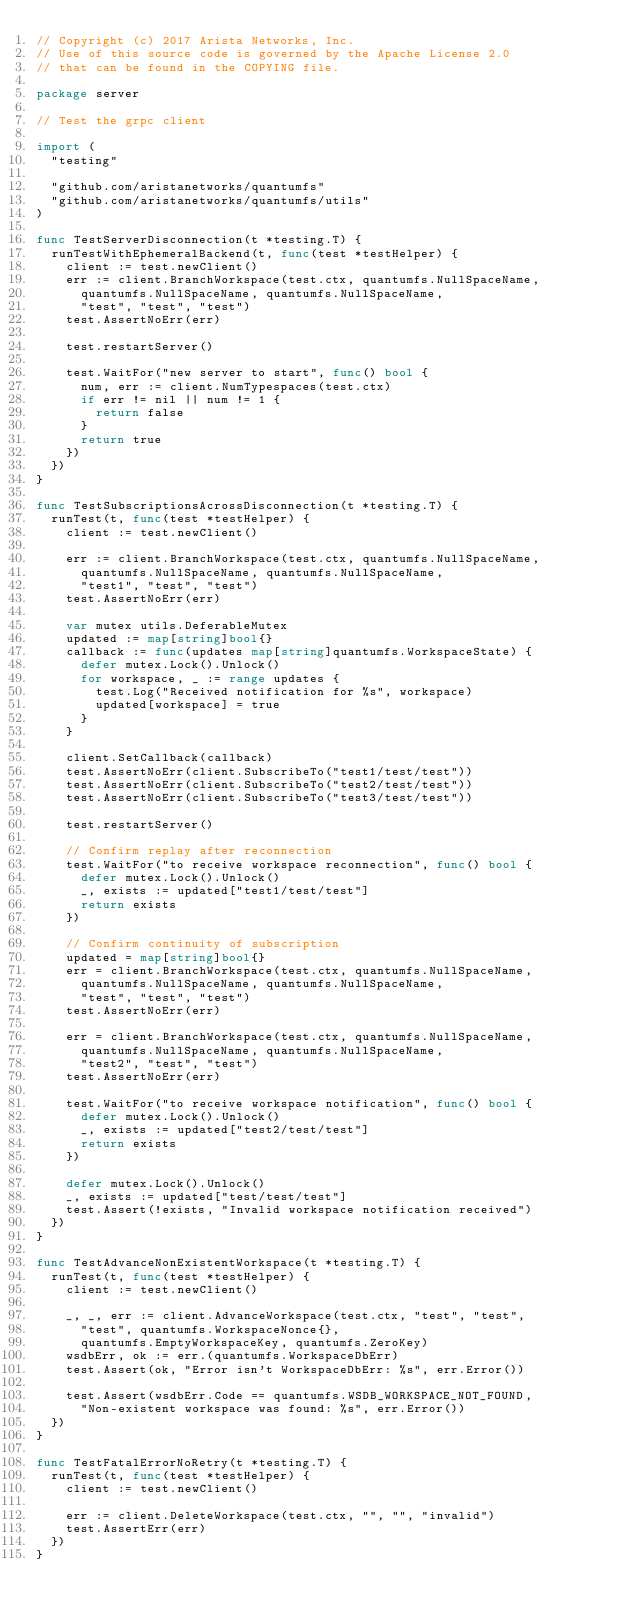<code> <loc_0><loc_0><loc_500><loc_500><_Go_>// Copyright (c) 2017 Arista Networks, Inc.
// Use of this source code is governed by the Apache License 2.0
// that can be found in the COPYING file.

package server

// Test the grpc client

import (
	"testing"

	"github.com/aristanetworks/quantumfs"
	"github.com/aristanetworks/quantumfs/utils"
)

func TestServerDisconnection(t *testing.T) {
	runTestWithEphemeralBackend(t, func(test *testHelper) {
		client := test.newClient()
		err := client.BranchWorkspace(test.ctx, quantumfs.NullSpaceName,
			quantumfs.NullSpaceName, quantumfs.NullSpaceName,
			"test", "test", "test")
		test.AssertNoErr(err)

		test.restartServer()

		test.WaitFor("new server to start", func() bool {
			num, err := client.NumTypespaces(test.ctx)
			if err != nil || num != 1 {
				return false
			}
			return true
		})
	})
}

func TestSubscriptionsAcrossDisconnection(t *testing.T) {
	runTest(t, func(test *testHelper) {
		client := test.newClient()

		err := client.BranchWorkspace(test.ctx, quantumfs.NullSpaceName,
			quantumfs.NullSpaceName, quantumfs.NullSpaceName,
			"test1", "test", "test")
		test.AssertNoErr(err)

		var mutex utils.DeferableMutex
		updated := map[string]bool{}
		callback := func(updates map[string]quantumfs.WorkspaceState) {
			defer mutex.Lock().Unlock()
			for workspace, _ := range updates {
				test.Log("Received notification for %s", workspace)
				updated[workspace] = true
			}
		}

		client.SetCallback(callback)
		test.AssertNoErr(client.SubscribeTo("test1/test/test"))
		test.AssertNoErr(client.SubscribeTo("test2/test/test"))
		test.AssertNoErr(client.SubscribeTo("test3/test/test"))

		test.restartServer()

		// Confirm replay after reconnection
		test.WaitFor("to receive workspace reconnection", func() bool {
			defer mutex.Lock().Unlock()
			_, exists := updated["test1/test/test"]
			return exists
		})

		// Confirm continuity of subscription
		updated = map[string]bool{}
		err = client.BranchWorkspace(test.ctx, quantumfs.NullSpaceName,
			quantumfs.NullSpaceName, quantumfs.NullSpaceName,
			"test", "test", "test")
		test.AssertNoErr(err)

		err = client.BranchWorkspace(test.ctx, quantumfs.NullSpaceName,
			quantumfs.NullSpaceName, quantumfs.NullSpaceName,
			"test2", "test", "test")
		test.AssertNoErr(err)

		test.WaitFor("to receive workspace notification", func() bool {
			defer mutex.Lock().Unlock()
			_, exists := updated["test2/test/test"]
			return exists
		})

		defer mutex.Lock().Unlock()
		_, exists := updated["test/test/test"]
		test.Assert(!exists, "Invalid workspace notification received")
	})
}

func TestAdvanceNonExistentWorkspace(t *testing.T) {
	runTest(t, func(test *testHelper) {
		client := test.newClient()

		_, _, err := client.AdvanceWorkspace(test.ctx, "test", "test",
			"test", quantumfs.WorkspaceNonce{},
			quantumfs.EmptyWorkspaceKey, quantumfs.ZeroKey)
		wsdbErr, ok := err.(quantumfs.WorkspaceDbErr)
		test.Assert(ok, "Error isn't WorkspaceDbErr: %s", err.Error())

		test.Assert(wsdbErr.Code == quantumfs.WSDB_WORKSPACE_NOT_FOUND,
			"Non-existent workspace was found: %s", err.Error())
	})
}

func TestFatalErrorNoRetry(t *testing.T) {
	runTest(t, func(test *testHelper) {
		client := test.newClient()

		err := client.DeleteWorkspace(test.ctx, "", "", "invalid")
		test.AssertErr(err)
	})
}
</code> 